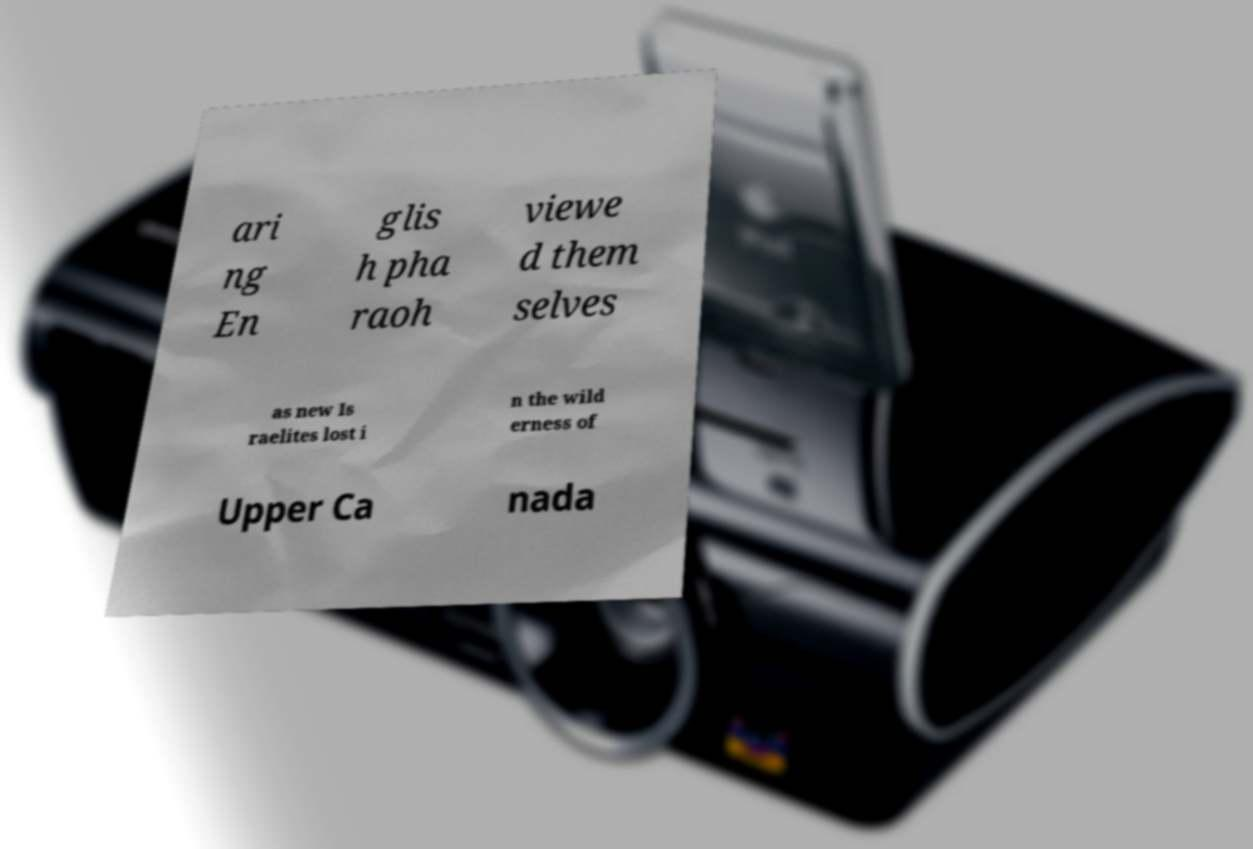There's text embedded in this image that I need extracted. Can you transcribe it verbatim? ari ng En glis h pha raoh viewe d them selves as new Is raelites lost i n the wild erness of Upper Ca nada 